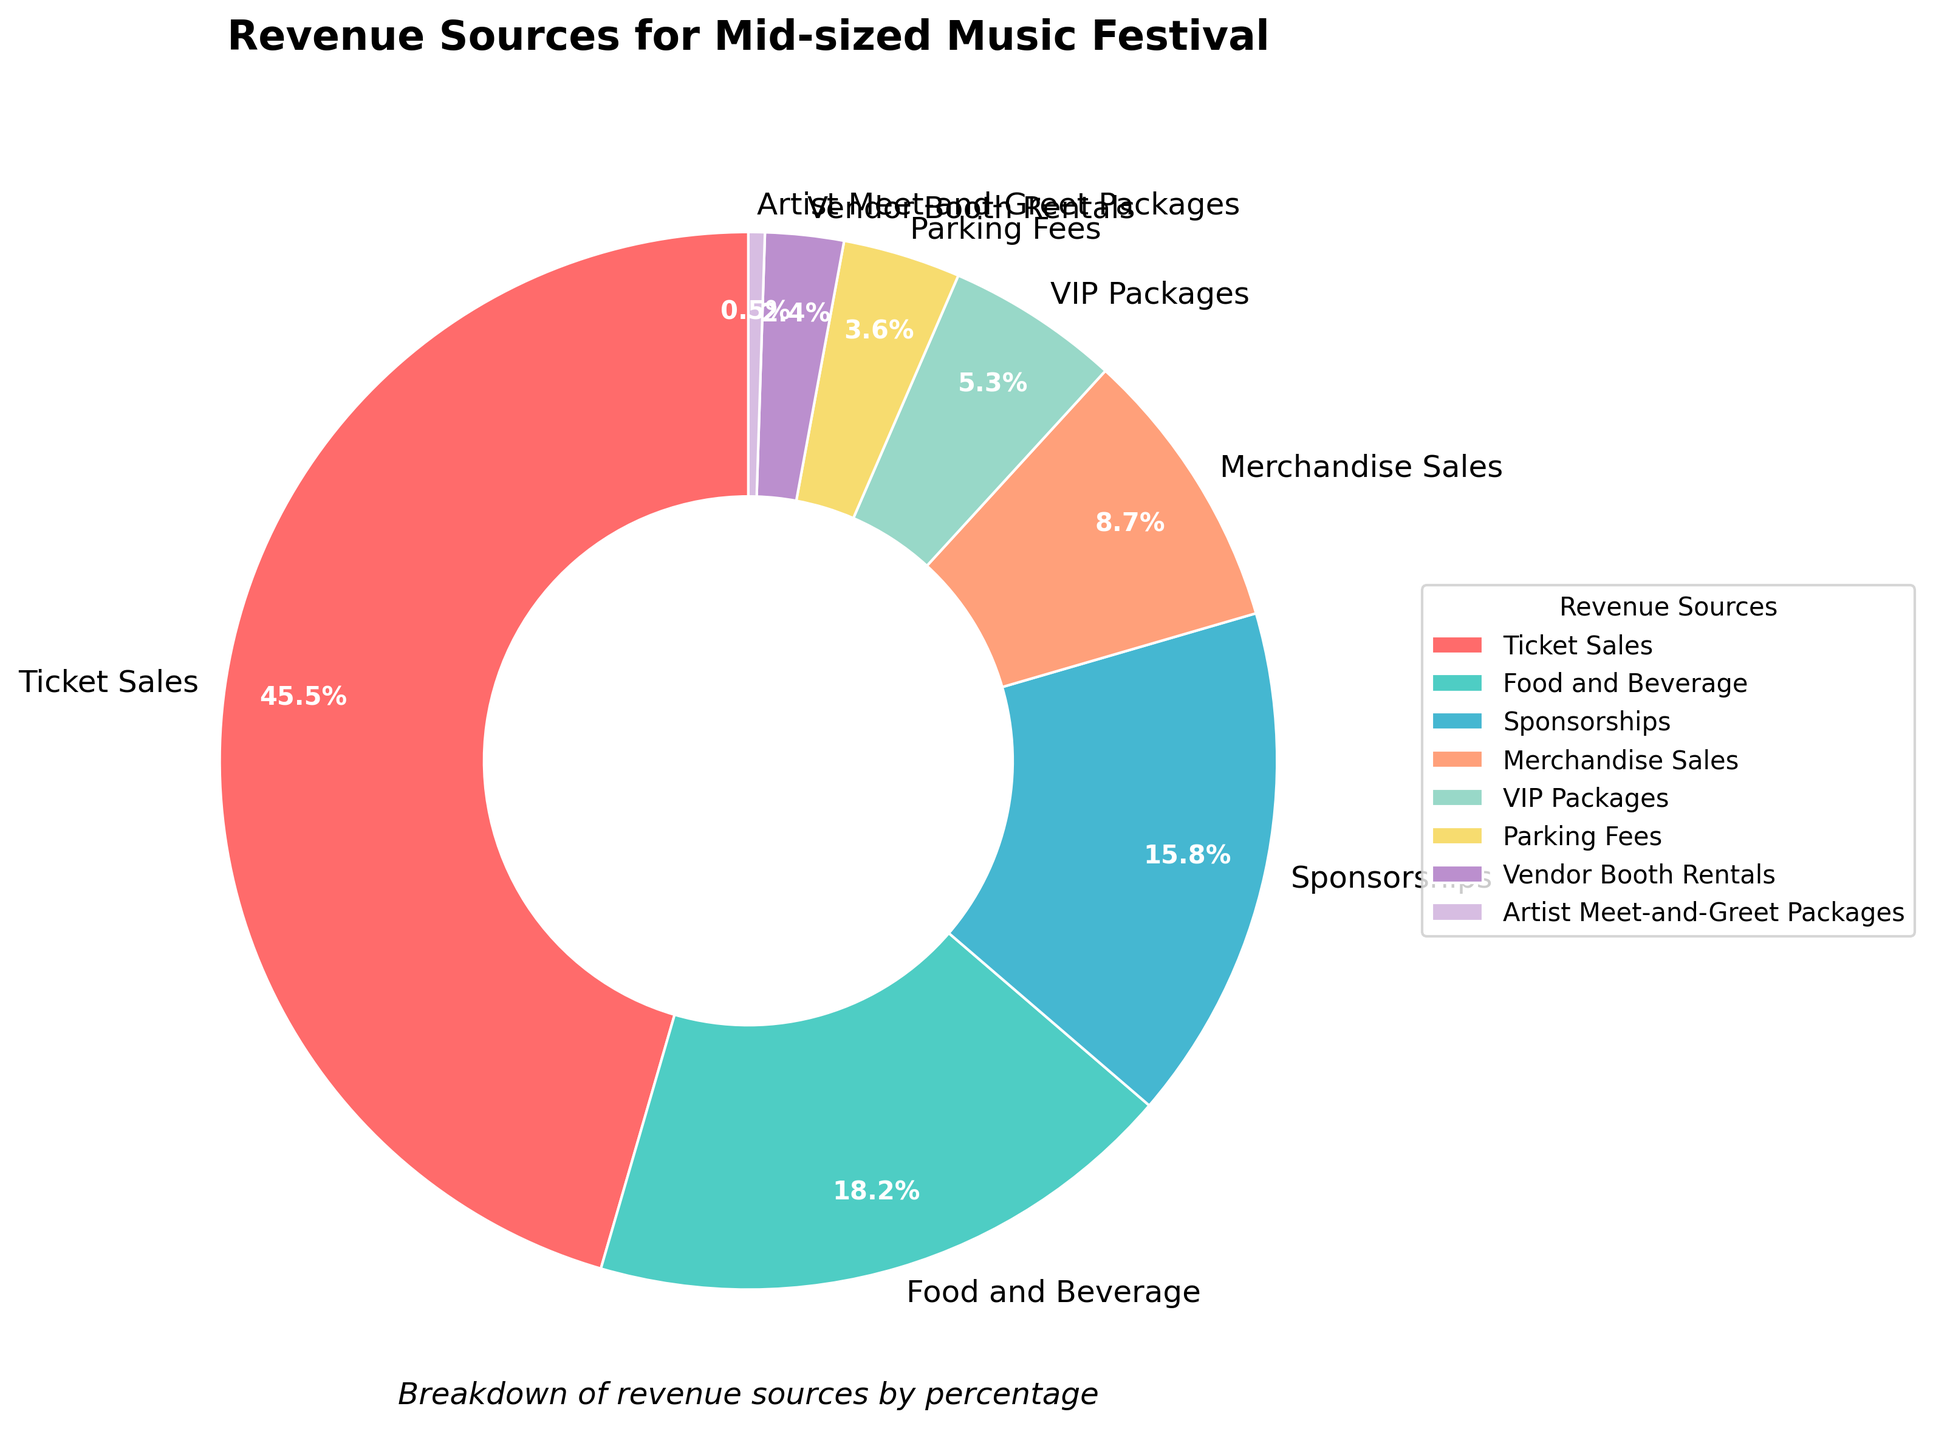Which revenue source is the highest contributor? The largest segment on the pie chart represents the revenue source with the highest percentage.
Answer: Ticket Sales What is the difference in percentage between Ticket Sales and Sponsorships? Ticket Sales contribute 45.5% and Sponsorships contribute 15.8%. The difference is calculated as 45.5% - 15.8%.
Answer: 29.7% Which two revenue sources together make up more than 60% of the total revenue? Ticket Sales contribute 45.5% and adding Food and Beverage which contribute 18.2%, the sum is 63.7%, which is more than 60%.
Answer: Ticket Sales and Food and Beverage How much less percentage do Merchandise Sales contribute compared to Ticket Sales? Ticket Sales contribute 45.5% and Merchandise Sales contribute 8.7%. The difference is calculated as 45.5% - 8.7%.
Answer: 36.8% What percentage do the bottom three revenue sources (by percentage) contribute in total? The bottom three revenue sources are Artist Meet-and-Greet Packages (0.5%), Vendor Booth Rentals (2.4%), and Parking Fees (3.6%). Adding them together, 0.5% + 2.4% + 3.6% = 6.5%.
Answer: 6.5% Is the percentage from VIP Packages greater or less than that from Merchandise Sales? The percentage from VIP Packages is 5.3% and from Merchandise Sales is 8.7%. Since 5.3% is less than 8.7%, VIP Packages are less.
Answer: Less Which color represents the source with the lowest percentage? The color representing the smallest segment of the pie chart, 0.5%, corresponds to Artist Meet-and-Greet Packages.
Answer: (Assuming the color given in the dataset) What is the combined percentage of Ticket Sales, Food and Beverage, and Sponsorships? Sum of Ticket Sales (45.5%), Food and Beverage (18.2%), and Sponsorships (15.8%) is 45.5% + 18.2% + 15.8% = 79.5%.
Answer: 79.5% Are there any sources that contribute less than 1% to the revenue? The segment representing Artist Meet-and-Greet Packages is marked as 0.5%, which is less than 1%.
Answer: Yes Which sources contribute between 5% and 10% of the total revenue? VIP Packages (5.3%) and Merchandise Sales (8.7%) fall within the range of 5% to 10%.
Answer: VIP Packages and Merchandise Sales 